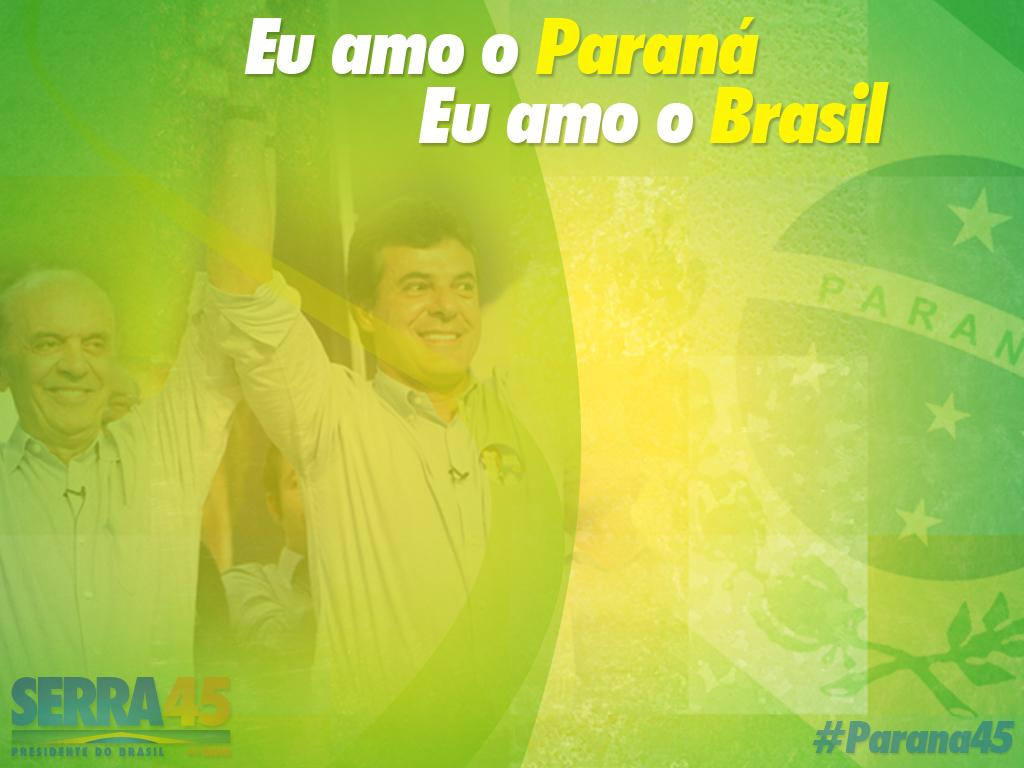What is present in the image that contains images and text? There is a poster in the image that contains images of people and text. Can you describe the images on the poster? The images on the poster contain pictures of people. What else can be found on the poster besides the images? There is text on the poster. How does the poster use a knot to convey its message? The poster does not use a knot to convey its message, as knots are not a form of communication or a component of posters. 